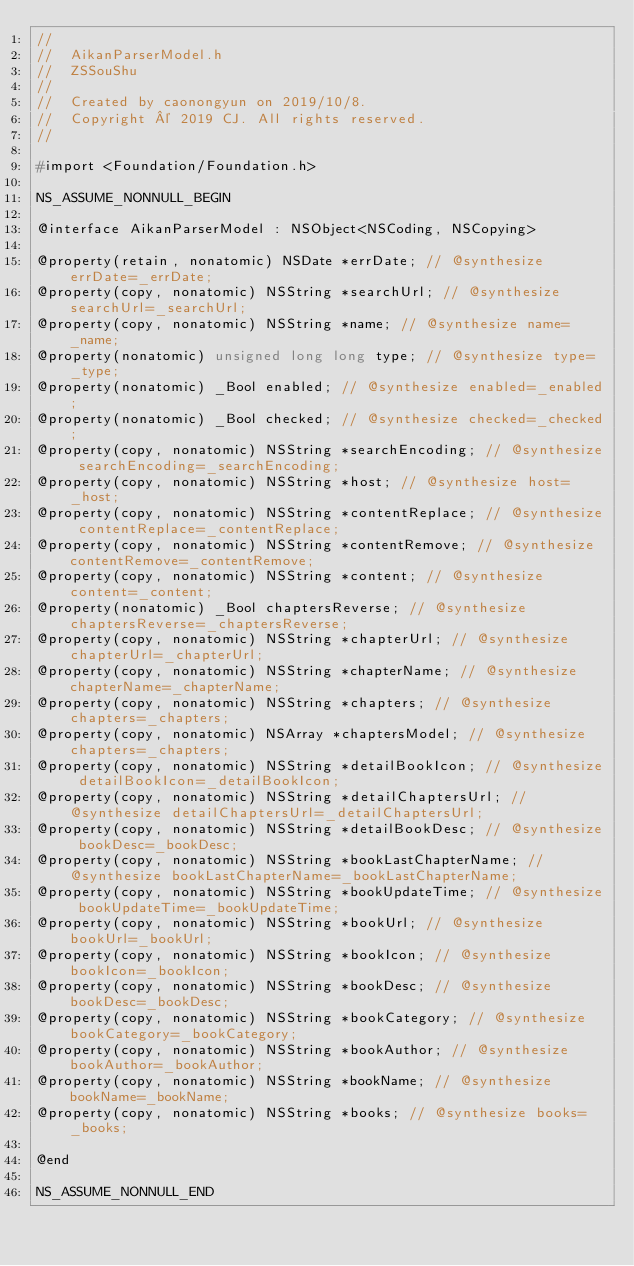<code> <loc_0><loc_0><loc_500><loc_500><_C_>//
//  AikanParserModel.h
//  ZSSouShu
//
//  Created by caonongyun on 2019/10/8.
//  Copyright © 2019 CJ. All rights reserved.
//

#import <Foundation/Foundation.h>

NS_ASSUME_NONNULL_BEGIN

@interface AikanParserModel : NSObject<NSCoding, NSCopying>

@property(retain, nonatomic) NSDate *errDate; // @synthesize errDate=_errDate;
@property(copy, nonatomic) NSString *searchUrl; // @synthesize searchUrl=_searchUrl;
@property(copy, nonatomic) NSString *name; // @synthesize name=_name;
@property(nonatomic) unsigned long long type; // @synthesize type=_type;
@property(nonatomic) _Bool enabled; // @synthesize enabled=_enabled;
@property(nonatomic) _Bool checked; // @synthesize checked=_checked;
@property(copy, nonatomic) NSString *searchEncoding; // @synthesize searchEncoding=_searchEncoding;
@property(copy, nonatomic) NSString *host; // @synthesize host=_host;
@property(copy, nonatomic) NSString *contentReplace; // @synthesize contentReplace=_contentReplace;
@property(copy, nonatomic) NSString *contentRemove; // @synthesize contentRemove=_contentRemove;
@property(copy, nonatomic) NSString *content; // @synthesize content=_content;
@property(nonatomic) _Bool chaptersReverse; // @synthesize chaptersReverse=_chaptersReverse;
@property(copy, nonatomic) NSString *chapterUrl; // @synthesize chapterUrl=_chapterUrl;
@property(copy, nonatomic) NSString *chapterName; // @synthesize chapterName=_chapterName;
@property(copy, nonatomic) NSString *chapters; // @synthesize chapters=_chapters;
@property(copy, nonatomic) NSArray *chaptersModel; // @synthesize chapters=_chapters;
@property(copy, nonatomic) NSString *detailBookIcon; // @synthesize detailBookIcon=_detailBookIcon;
@property(copy, nonatomic) NSString *detailChaptersUrl; // @synthesize detailChaptersUrl=_detailChaptersUrl;
@property(copy, nonatomic) NSString *detailBookDesc; // @synthesize bookDesc=_bookDesc;
@property(copy, nonatomic) NSString *bookLastChapterName; // @synthesize bookLastChapterName=_bookLastChapterName;
@property(copy, nonatomic) NSString *bookUpdateTime; // @synthesize bookUpdateTime=_bookUpdateTime;
@property(copy, nonatomic) NSString *bookUrl; // @synthesize bookUrl=_bookUrl;
@property(copy, nonatomic) NSString *bookIcon; // @synthesize bookIcon=_bookIcon;
@property(copy, nonatomic) NSString *bookDesc; // @synthesize bookDesc=_bookDesc;
@property(copy, nonatomic) NSString *bookCategory; // @synthesize bookCategory=_bookCategory;
@property(copy, nonatomic) NSString *bookAuthor; // @synthesize bookAuthor=_bookAuthor;
@property(copy, nonatomic) NSString *bookName; // @synthesize bookName=_bookName;
@property(copy, nonatomic) NSString *books; // @synthesize books=_books;

@end

NS_ASSUME_NONNULL_END
</code> 